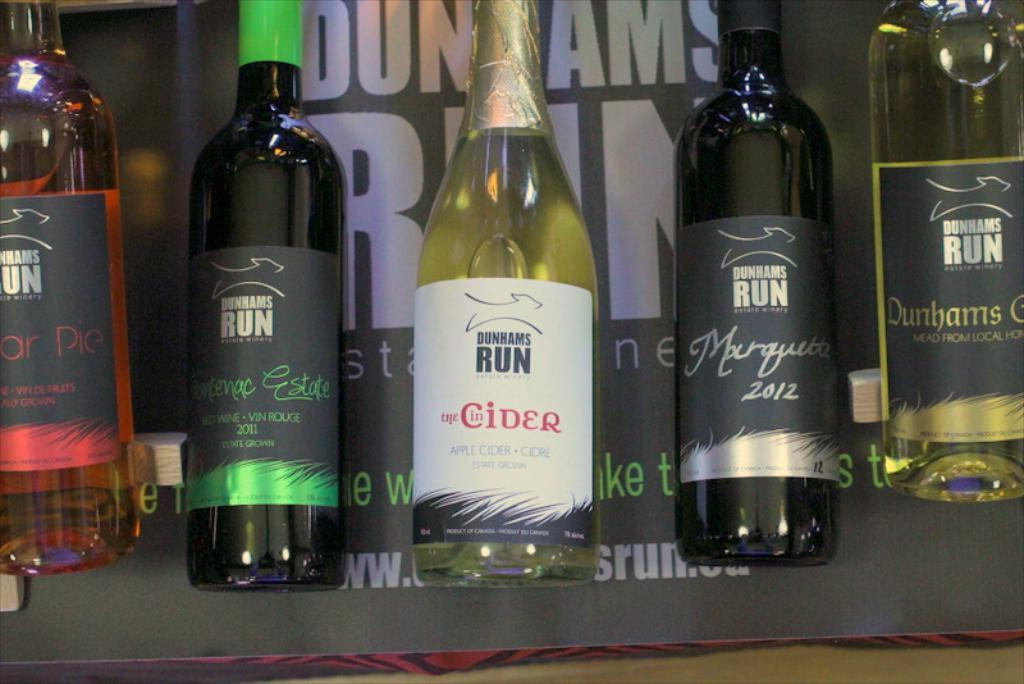<image>
Give a short and clear explanation of the subsequent image. Five bottles of various Dunhams Run beverages are displayed in front of a Dunhams Run sign. 